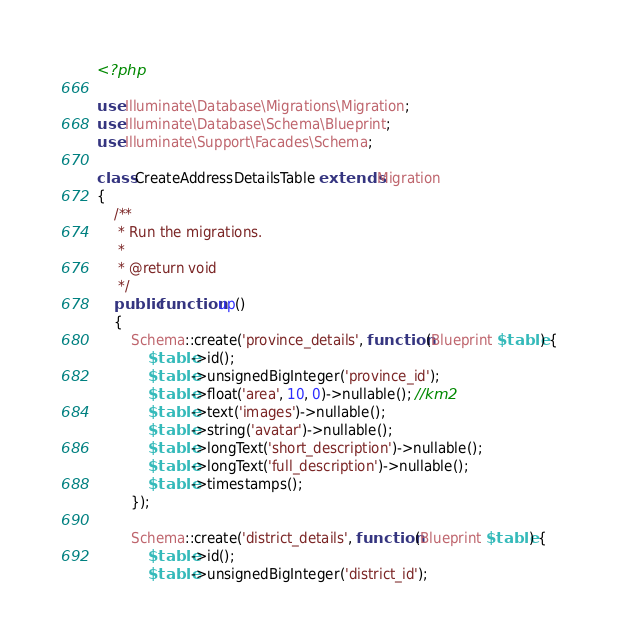Convert code to text. <code><loc_0><loc_0><loc_500><loc_500><_PHP_><?php

use Illuminate\Database\Migrations\Migration;
use Illuminate\Database\Schema\Blueprint;
use Illuminate\Support\Facades\Schema;

class CreateAddressDetailsTable extends Migration
{
    /**
     * Run the migrations.
     *
     * @return void
     */
    public function up()
    {
        Schema::create('province_details', function (Blueprint $table) {
            $table->id();
            $table->unsignedBigInteger('province_id');
            $table->float('area', 10, 0)->nullable(); //km2
            $table->text('images')->nullable();
            $table->string('avatar')->nullable();
            $table->longText('short_description')->nullable();
            $table->longText('full_description')->nullable();
            $table->timestamps();
        });

        Schema::create('district_details', function (Blueprint $table) {
            $table->id();
            $table->unsignedBigInteger('district_id');</code> 